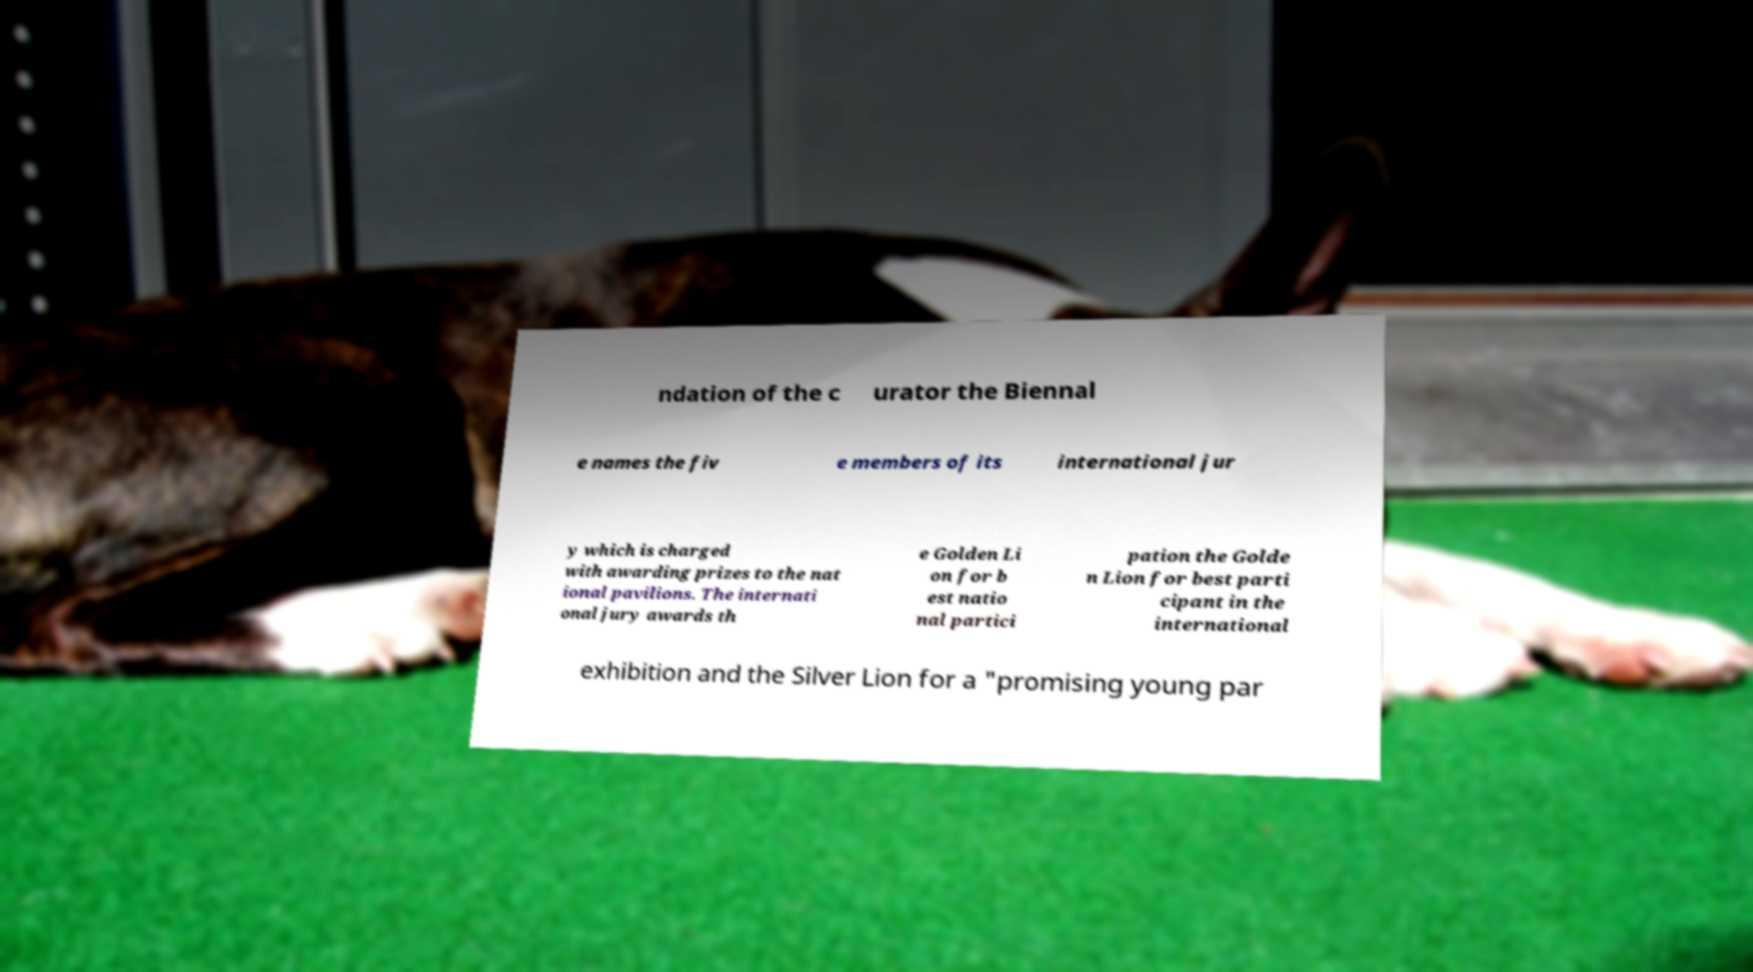Can you accurately transcribe the text from the provided image for me? ndation of the c urator the Biennal e names the fiv e members of its international jur y which is charged with awarding prizes to the nat ional pavilions. The internati onal jury awards th e Golden Li on for b est natio nal partici pation the Golde n Lion for best parti cipant in the international exhibition and the Silver Lion for a "promising young par 